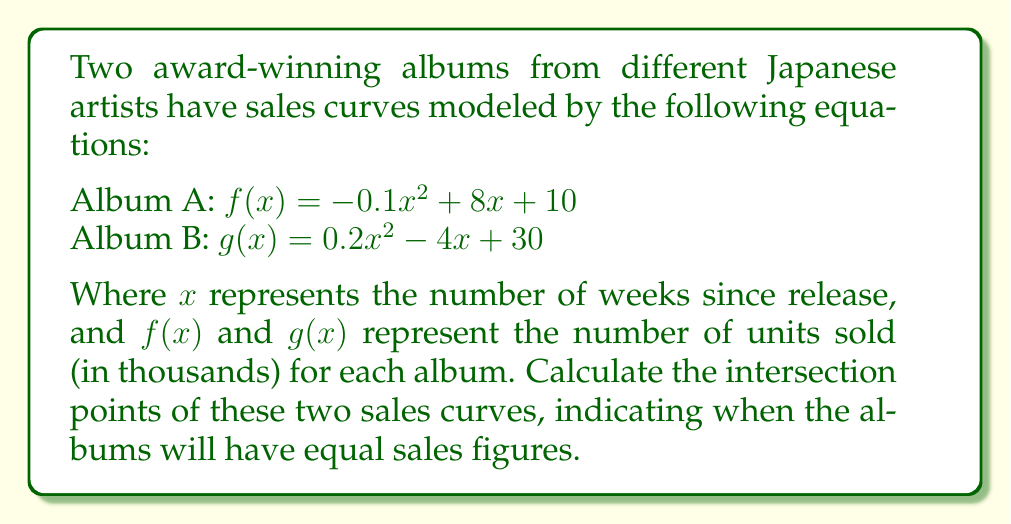Can you solve this math problem? To find the intersection points, we need to solve the equation $f(x) = g(x)$:

1) Set up the equation:
   $-0.1x^2 + 8x + 10 = 0.2x^2 - 4x + 30$

2) Rearrange terms to standard form:
   $0.3x^2 - 12x + 20 = 0$

3) This is a quadratic equation in the form $ax^2 + bx + c = 0$, where:
   $a = 0.3$, $b = -12$, and $c = 20$

4) Use the quadratic formula: $x = \frac{-b \pm \sqrt{b^2 - 4ac}}{2a}$

5) Substitute the values:
   $x = \frac{12 \pm \sqrt{(-12)^2 - 4(0.3)(20)}}{2(0.3)}$

6) Simplify:
   $x = \frac{12 \pm \sqrt{144 - 24}}{0.6} = \frac{12 \pm \sqrt{120}}{0.6}$

7) Simplify further:
   $x = \frac{12 \pm 2\sqrt{30}}{0.6} = 20 \pm \frac{2\sqrt{30}}{0.6}$

8) Final result:
   $x_1 = 20 + \frac{2\sqrt{30}}{0.6} \approx 38.27$
   $x_2 = 20 - \frac{2\sqrt{30}}{0.6} \approx 1.73$

These x-values represent the number of weeks after release when the album sales are equal.
Answer: The intersection points occur at approximately 1.73 weeks and 38.27 weeks after release. 